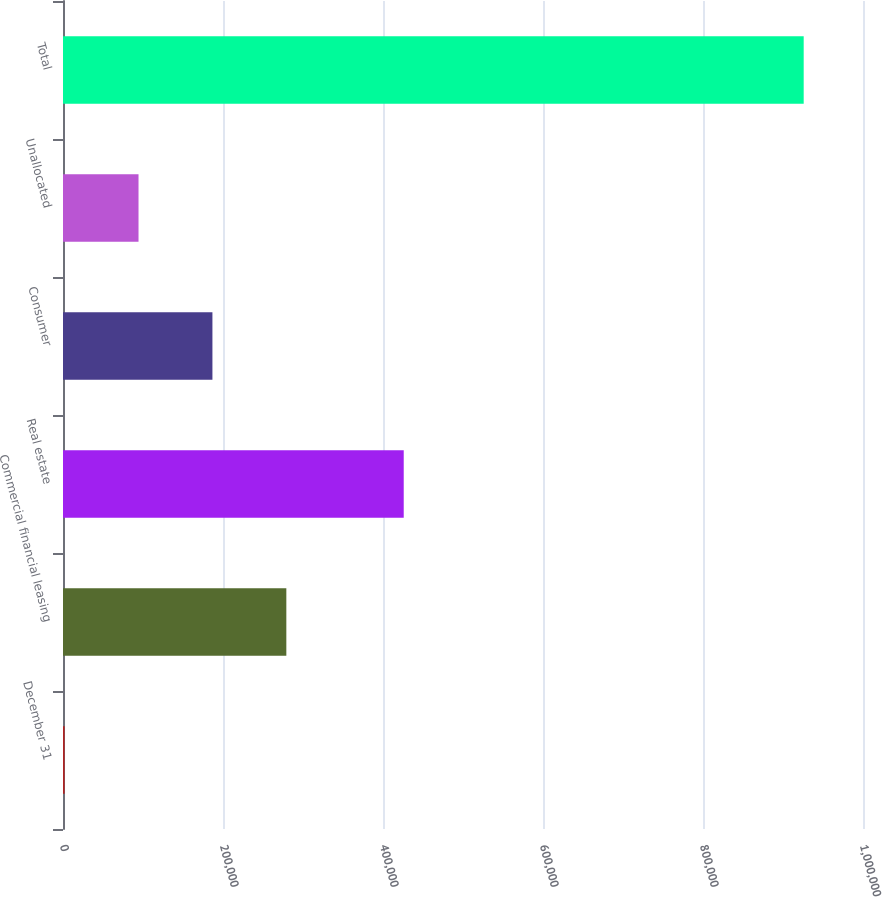Convert chart. <chart><loc_0><loc_0><loc_500><loc_500><bar_chart><fcel>December 31<fcel>Commercial financial leasing<fcel>Real estate<fcel>Consumer<fcel>Unallocated<fcel>Total<nl><fcel>2012<fcel>279166<fcel>425908<fcel>186782<fcel>94396.8<fcel>925860<nl></chart> 